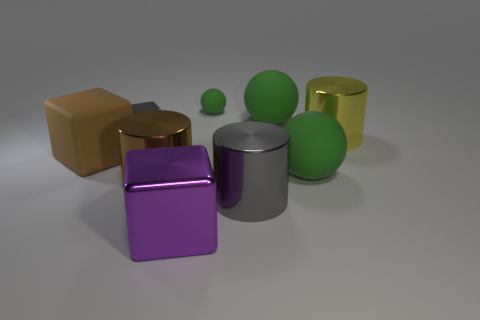Subtract all large balls. How many balls are left? 1 Subtract all purple blocks. How many blocks are left? 2 Add 1 small shiny blocks. How many objects exist? 10 Subtract all spheres. How many objects are left? 6 Subtract 1 balls. How many balls are left? 2 Subtract all brown spheres. Subtract all cyan cylinders. How many spheres are left? 3 Subtract all brown rubber blocks. Subtract all small gray metal cubes. How many objects are left? 7 Add 7 small balls. How many small balls are left? 8 Add 5 gray things. How many gray things exist? 7 Subtract 0 blue cubes. How many objects are left? 9 